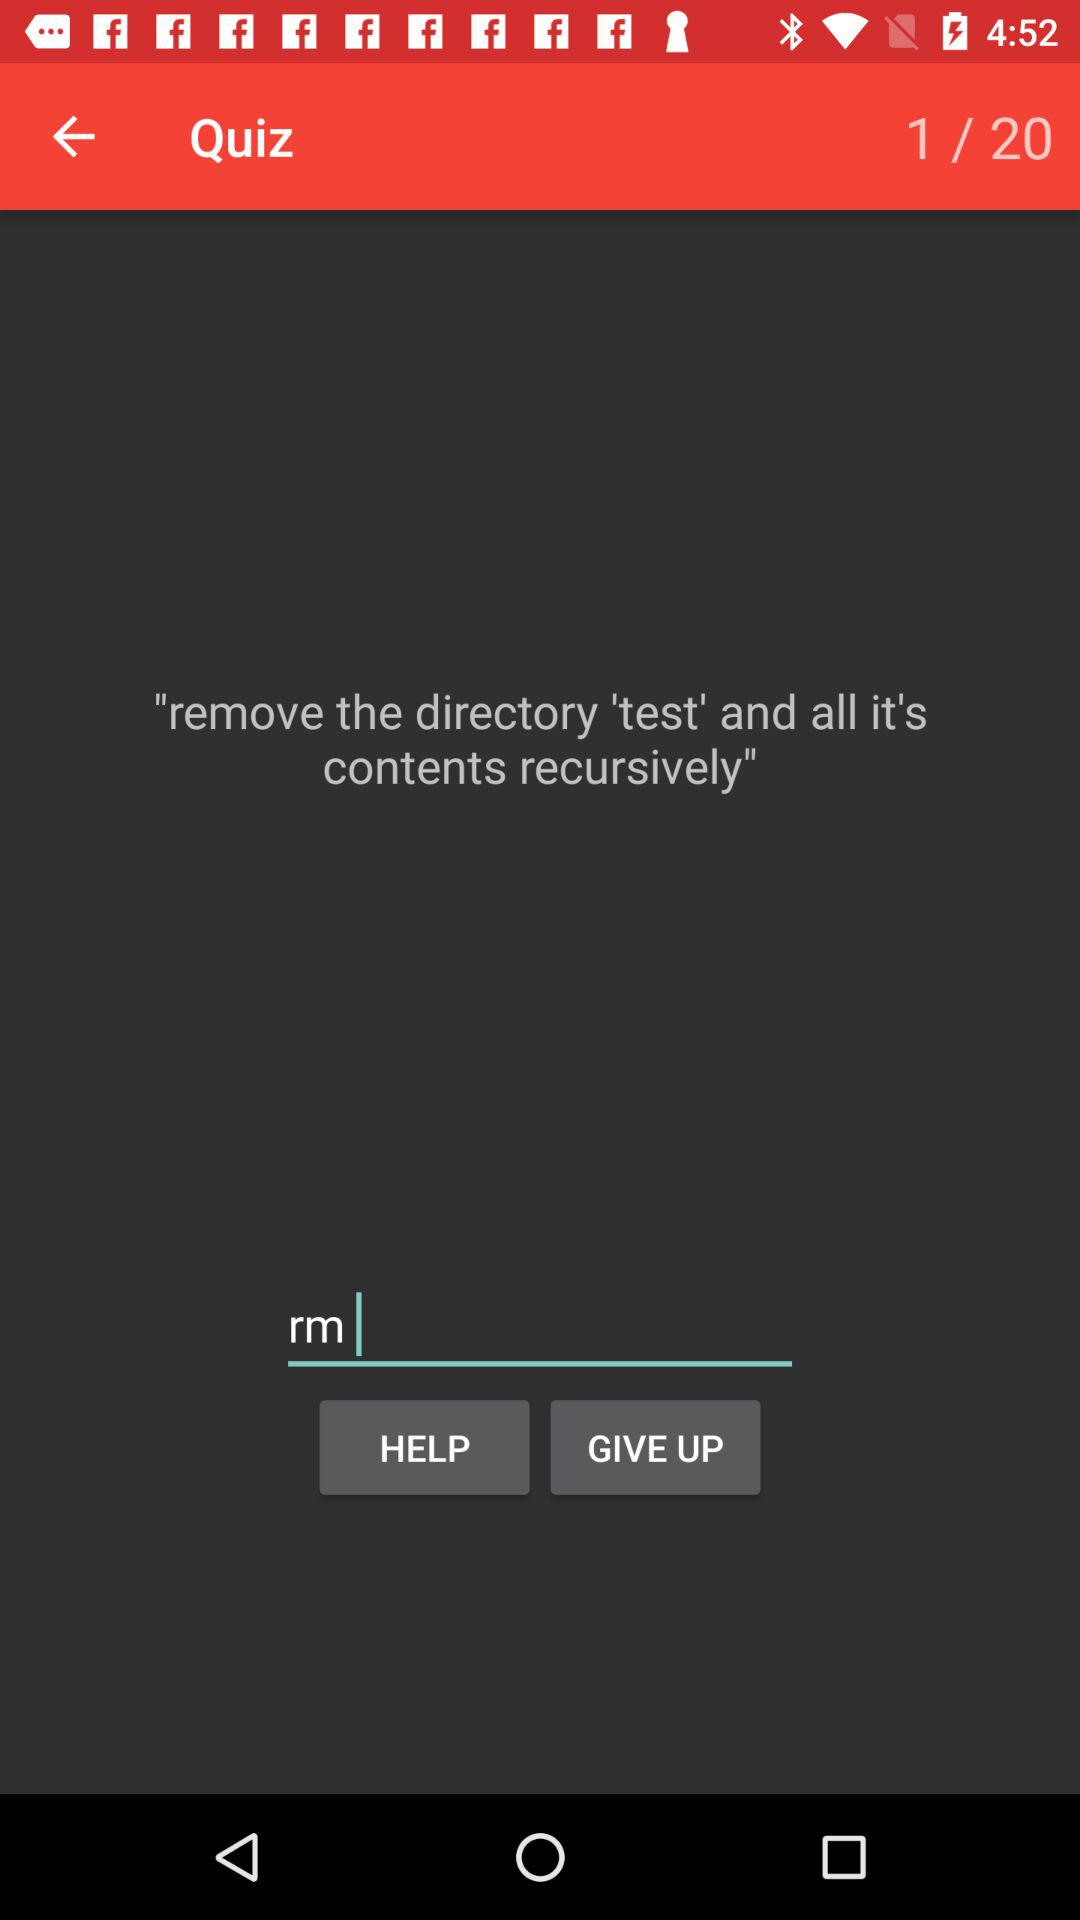At which question am I? You are at the first question. 